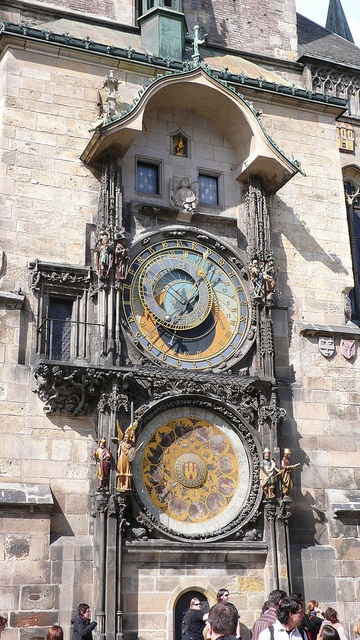Describe the objects in this image and their specific colors. I can see clock in black, gray, darkgray, and lightgray tones, clock in black, darkgray, gray, and tan tones, people in black, gray, darkgray, and lightgray tones, people in black, white, gray, and brown tones, and people in black and gray tones in this image. 